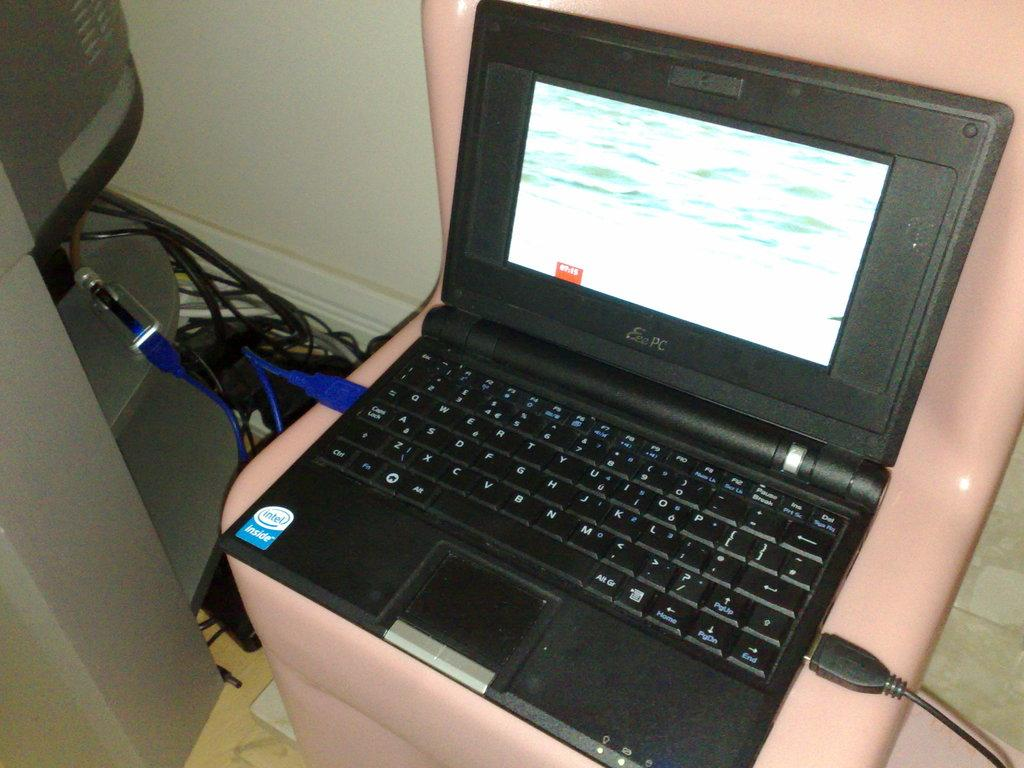<image>
Write a terse but informative summary of the picture. The black laptop pictured is an Eee PC. 